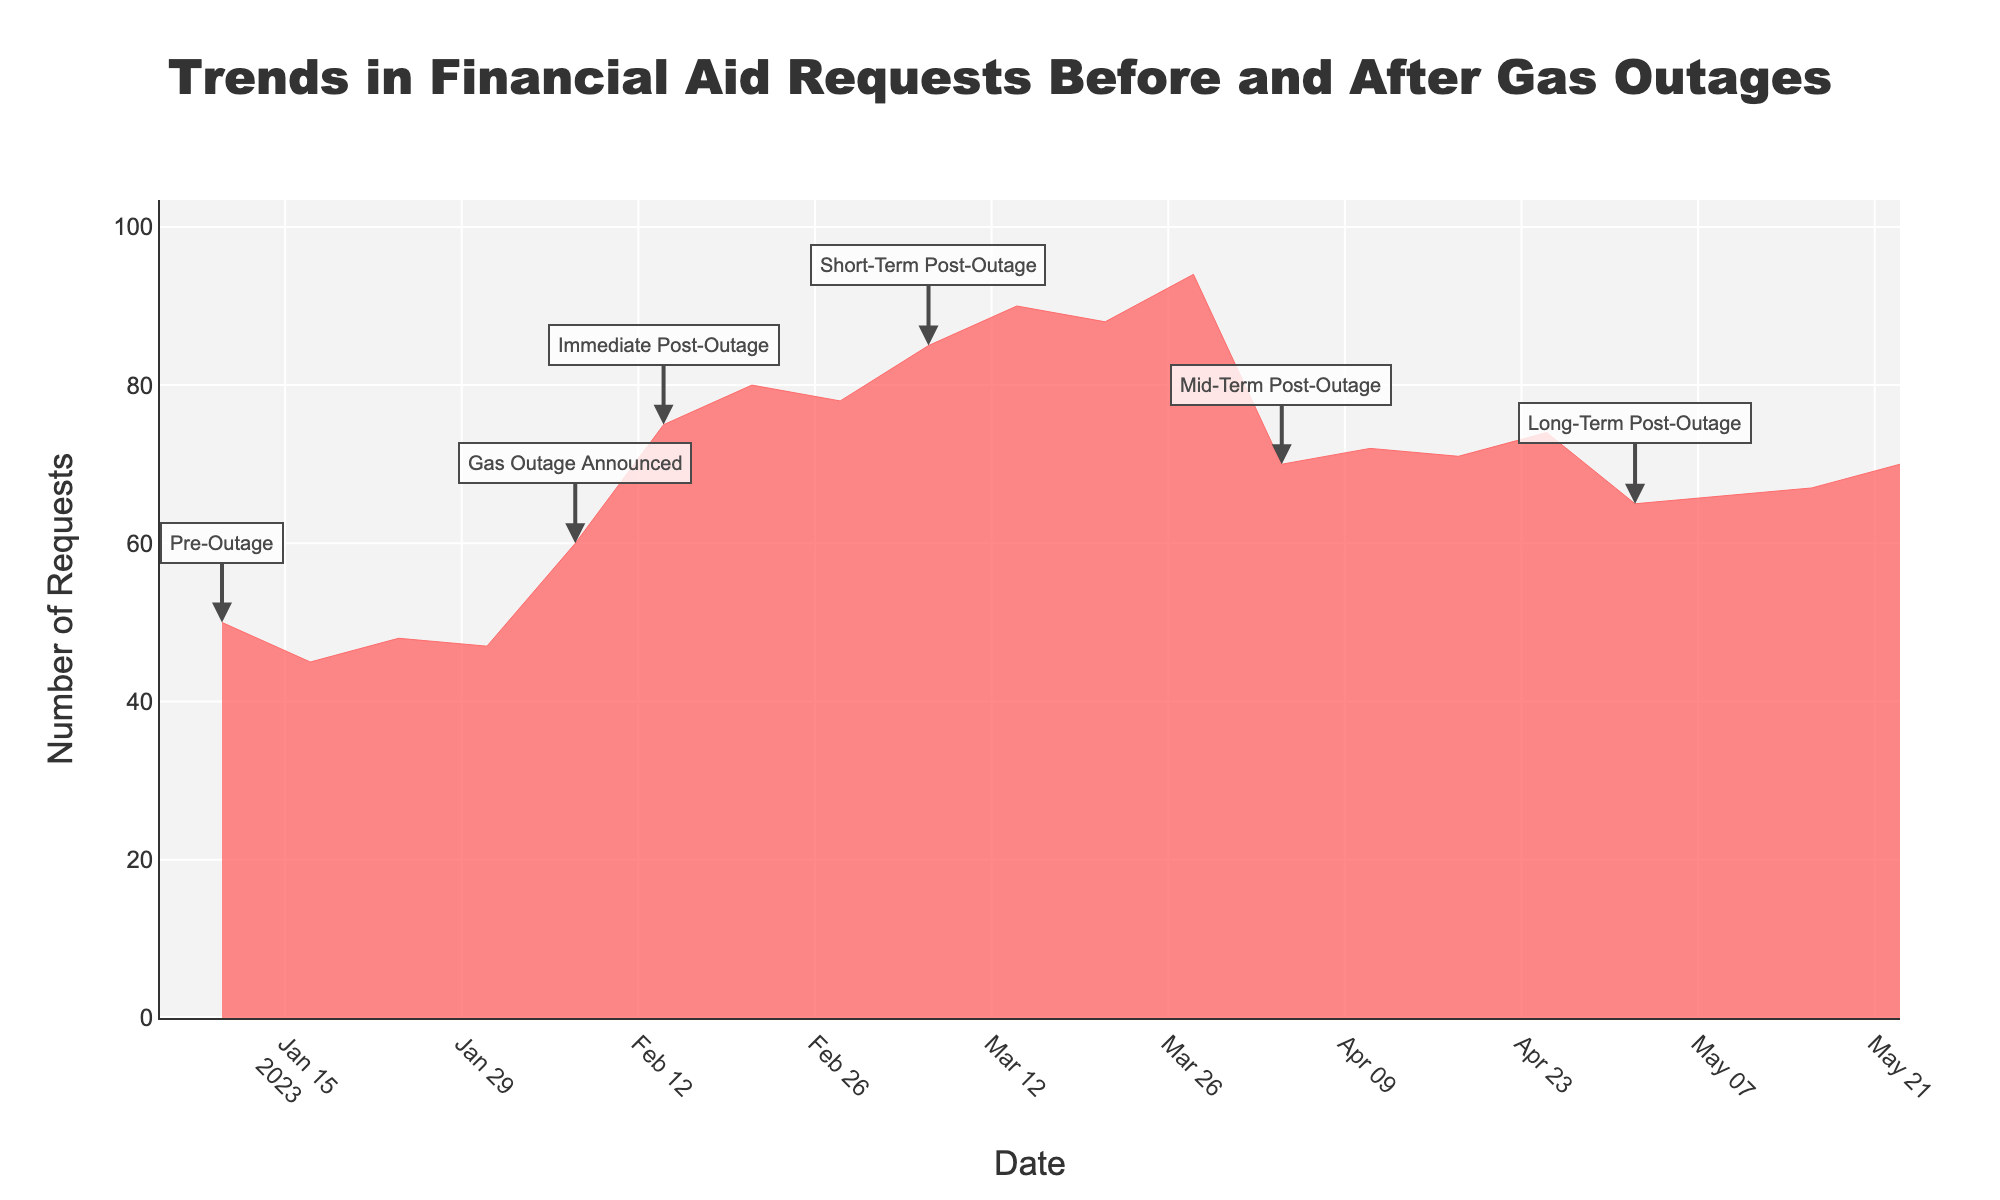What is the title of the figure? The title is usually displayed prominently at the top of a figure. In this case, the title is "Trends in Financial Aid Requests Before and After Gas Outages", as specified in the provided code.
Answer: Trends in Financial Aid Requests Before and After Gas Outages How many distinct events are indicated in the figure? By checking the unique events listed in the dataset and annotated in the graph, the distinct events are "Pre-Outage", "Gas Outage Announced", "Immediate Post-Outage", "Short-Term Post-Outage", "Mid-Term Post-Outage", and "Long-Term Post-Outage".
Answer: 6 When did the number of financial aid requests peak? By examining the values of financial aid requests over time in the dataset and graph, the highest value, 94, is found on March 28, 2023.
Answer: March 28, 2023 How did the financial aid requests change immediately after the gas outage was announced? Comparing the financial aid requests on February 7 (Gas Outage Announced) and the following dates, the requests increased from 60 to 75 on February 14.
Answer: Increased from 60 to 75 What are the financial aid request trends before and after the gas outage announcement? To identify the trends, we observe that before February 7, requests mostly hovered around 45-50. After the announcement, the requests increased sharply and remained higher than the pre-outage period.
Answer: Increased after the announcement During which period did the financial aid requests start to decline after rising? By examining the trends, requests rise until March 28 (94) and then decline during "Mid-Term Post-Outage" starting April 4 (70).
Answer: Mid-Term Post-Outage Which period shows the highest variation in the number of financial aid requests? By comparing the changes within each period, Short-Term Post-Outage shows notable increases and reaches a peak of 94.
Answer: Short-Term Post-Outage What is the trend in financial aid requests during the Long-Term Post-Outage period? During "Long-Term Post-Outage", the number of requests starts at 65 on May 2 and gradually increases to 70 by May 23.
Answer: Gradually increased 